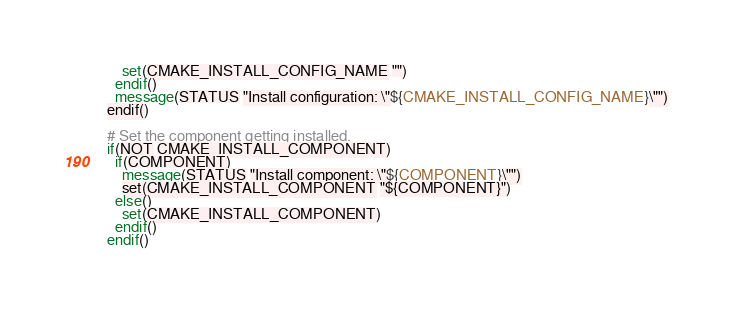<code> <loc_0><loc_0><loc_500><loc_500><_CMake_>    set(CMAKE_INSTALL_CONFIG_NAME "")
  endif()
  message(STATUS "Install configuration: \"${CMAKE_INSTALL_CONFIG_NAME}\"")
endif()

# Set the component getting installed.
if(NOT CMAKE_INSTALL_COMPONENT)
  if(COMPONENT)
    message(STATUS "Install component: \"${COMPONENT}\"")
    set(CMAKE_INSTALL_COMPONENT "${COMPONENT}")
  else()
    set(CMAKE_INSTALL_COMPONENT)
  endif()
endif()
</code> 